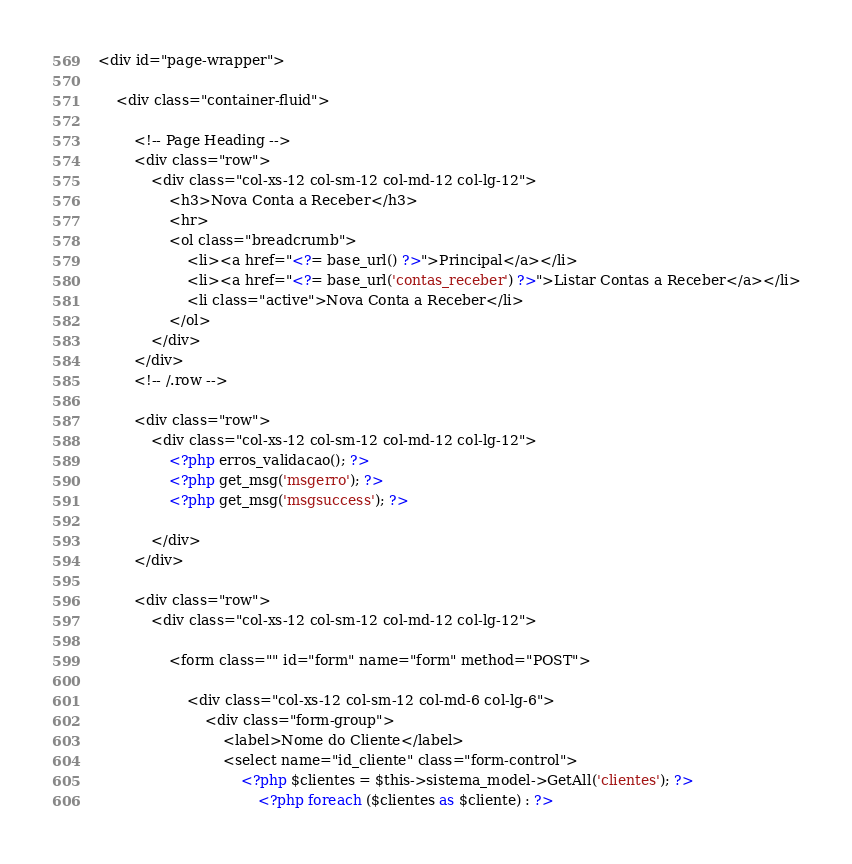Convert code to text. <code><loc_0><loc_0><loc_500><loc_500><_PHP_><div id="page-wrapper">

    <div class="container-fluid">

        <!-- Page Heading -->
        <div class="row">
            <div class="col-xs-12 col-sm-12 col-md-12 col-lg-12">                
                <h3>Nova Conta a Receber</h3>
                <hr>
                <ol class="breadcrumb">
                    <li><a href="<?= base_url() ?>">Principal</a></li>
                    <li><a href="<?= base_url('contas_receber') ?>">Listar Contas a Receber</a></li>
                    <li class="active">Nova Conta a Receber</li>
                </ol>
            </div>
        </div>
        <!-- /.row -->

        <div class="row">
            <div class="col-xs-12 col-sm-12 col-md-12 col-lg-12">  
                <?php erros_validacao(); ?>
                <?php get_msg('msgerro'); ?>
                <?php get_msg('msgsuccess'); ?>
                    
            </div>
        </div>

        <div class="row">
            <div class="col-xs-12 col-sm-12 col-md-12 col-lg-12">   

                <form class="" id="form" name="form" method="POST">

                    <div class="col-xs-12 col-sm-12 col-md-6 col-lg-6">   
                        <div class="form-group">
                            <label>Nome do Cliente</label>
                            <select name="id_cliente" class="form-control">
                                <?php $clientes = $this->sistema_model->GetAll('clientes'); ?>
                                    <?php foreach ($clientes as $cliente) : ?></code> 